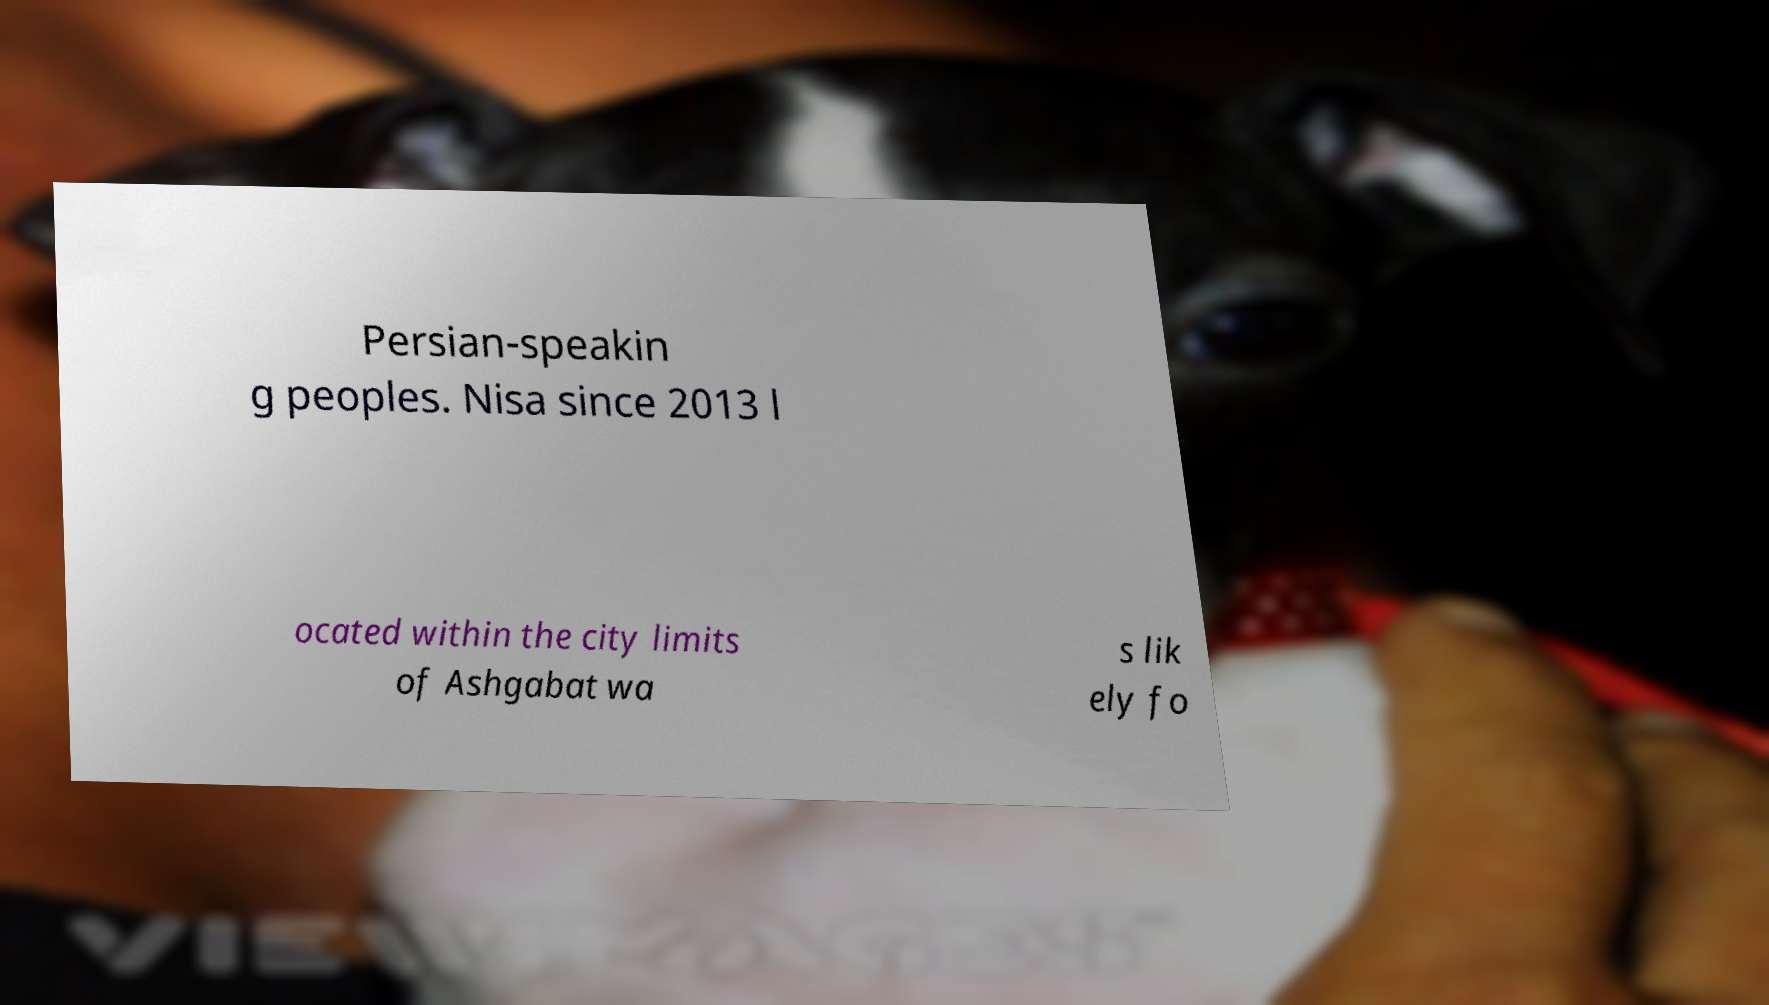Please identify and transcribe the text found in this image. Persian-speakin g peoples. Nisa since 2013 l ocated within the city limits of Ashgabat wa s lik ely fo 